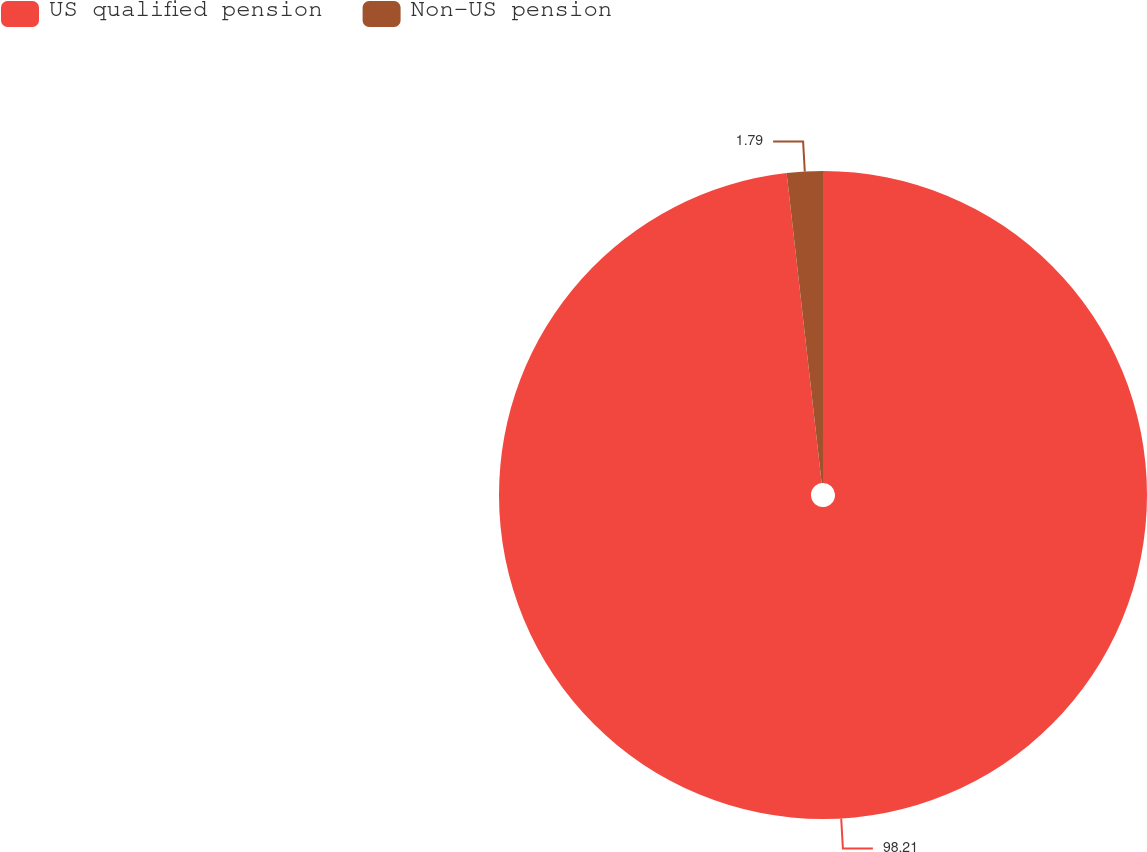Convert chart. <chart><loc_0><loc_0><loc_500><loc_500><pie_chart><fcel>US qualified pension<fcel>Non-US pension<nl><fcel>98.21%<fcel>1.79%<nl></chart> 